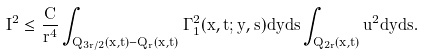<formula> <loc_0><loc_0><loc_500><loc_500>I ^ { 2 } \leq \frac { C } { r ^ { 4 } } \int _ { Q _ { 3 r / 2 } ( x , t ) - Q _ { r } ( x , t ) } \Gamma _ { 1 } ^ { 2 } ( x , t ; y , s ) d y d s \int _ { Q _ { 2 r } ( x , t ) } u ^ { 2 } d y d s .</formula> 